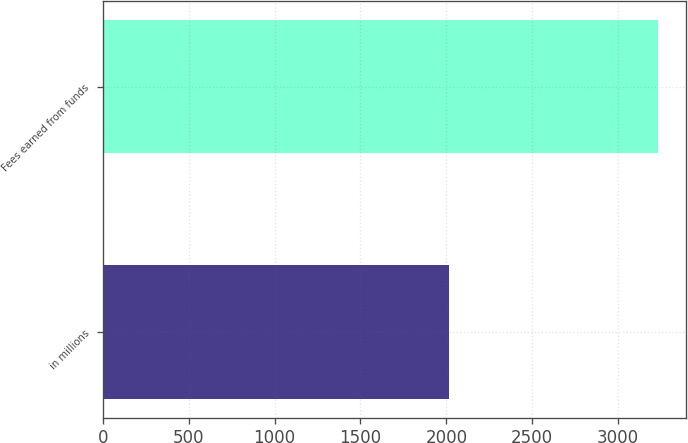Convert chart to OTSL. <chart><loc_0><loc_0><loc_500><loc_500><bar_chart><fcel>in millions<fcel>Fees earned from funds<nl><fcel>2014<fcel>3232<nl></chart> 